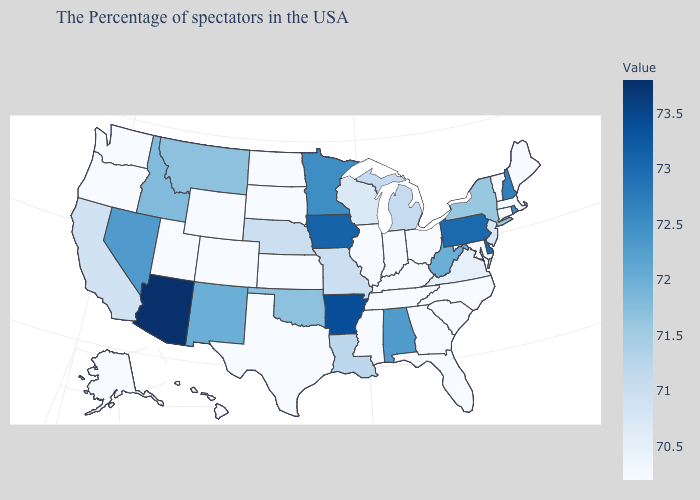Which states hav the highest value in the MidWest?
Concise answer only. Iowa. Is the legend a continuous bar?
Give a very brief answer. Yes. Which states hav the highest value in the Northeast?
Short answer required. Pennsylvania. Which states have the lowest value in the USA?
Keep it brief. Maine, Massachusetts, Vermont, Connecticut, Maryland, North Carolina, South Carolina, Ohio, Florida, Georgia, Kentucky, Indiana, Tennessee, Illinois, Mississippi, Kansas, Texas, South Dakota, North Dakota, Wyoming, Colorado, Utah, Washington, Oregon, Alaska, Hawaii. 